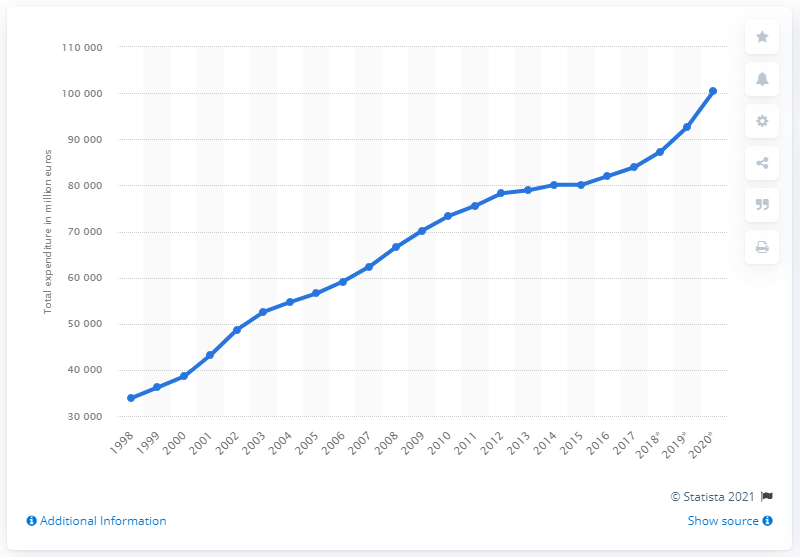Point out several critical features in this image. In 2020, the national healthcare expenditure was approximately 100,451,000,000 dollars. 